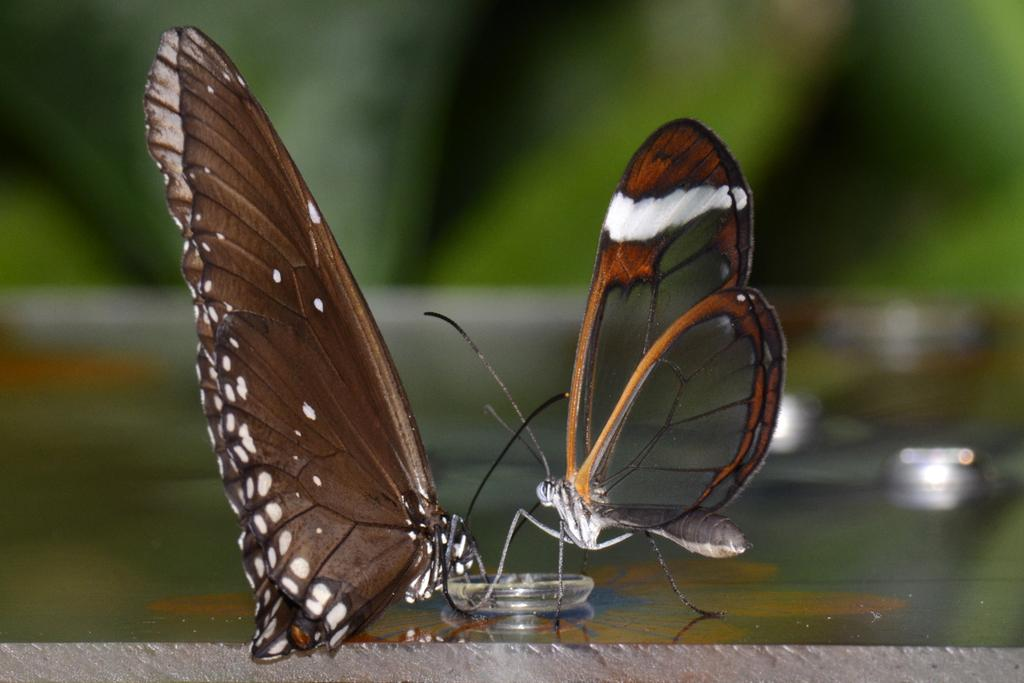What is the main subject of the image? There are two butterflies in the center of the image. Can you describe the background of the image? The background of the image is blurry. What year is depicted in the image? There is no specific year depicted in the image, as it features two butterflies and a blurry background. How many ants can be seen interacting with the butterflies in the image? There are no ants present in the image; it features two butterflies and a blurry background. 